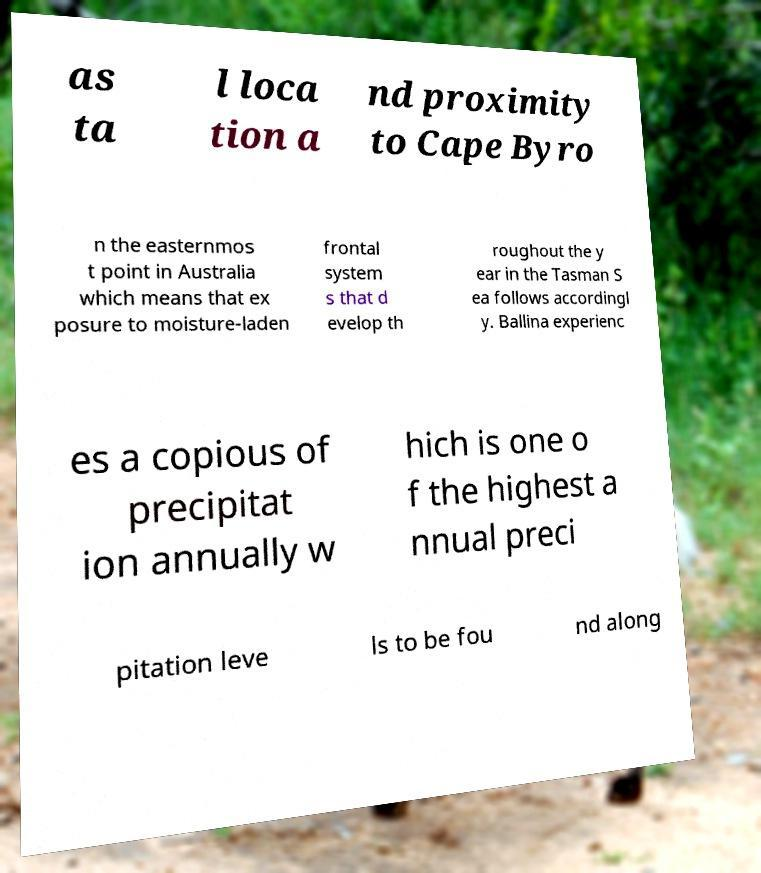What messages or text are displayed in this image? I need them in a readable, typed format. as ta l loca tion a nd proximity to Cape Byro n the easternmos t point in Australia which means that ex posure to moisture-laden frontal system s that d evelop th roughout the y ear in the Tasman S ea follows accordingl y. Ballina experienc es a copious of precipitat ion annually w hich is one o f the highest a nnual preci pitation leve ls to be fou nd along 